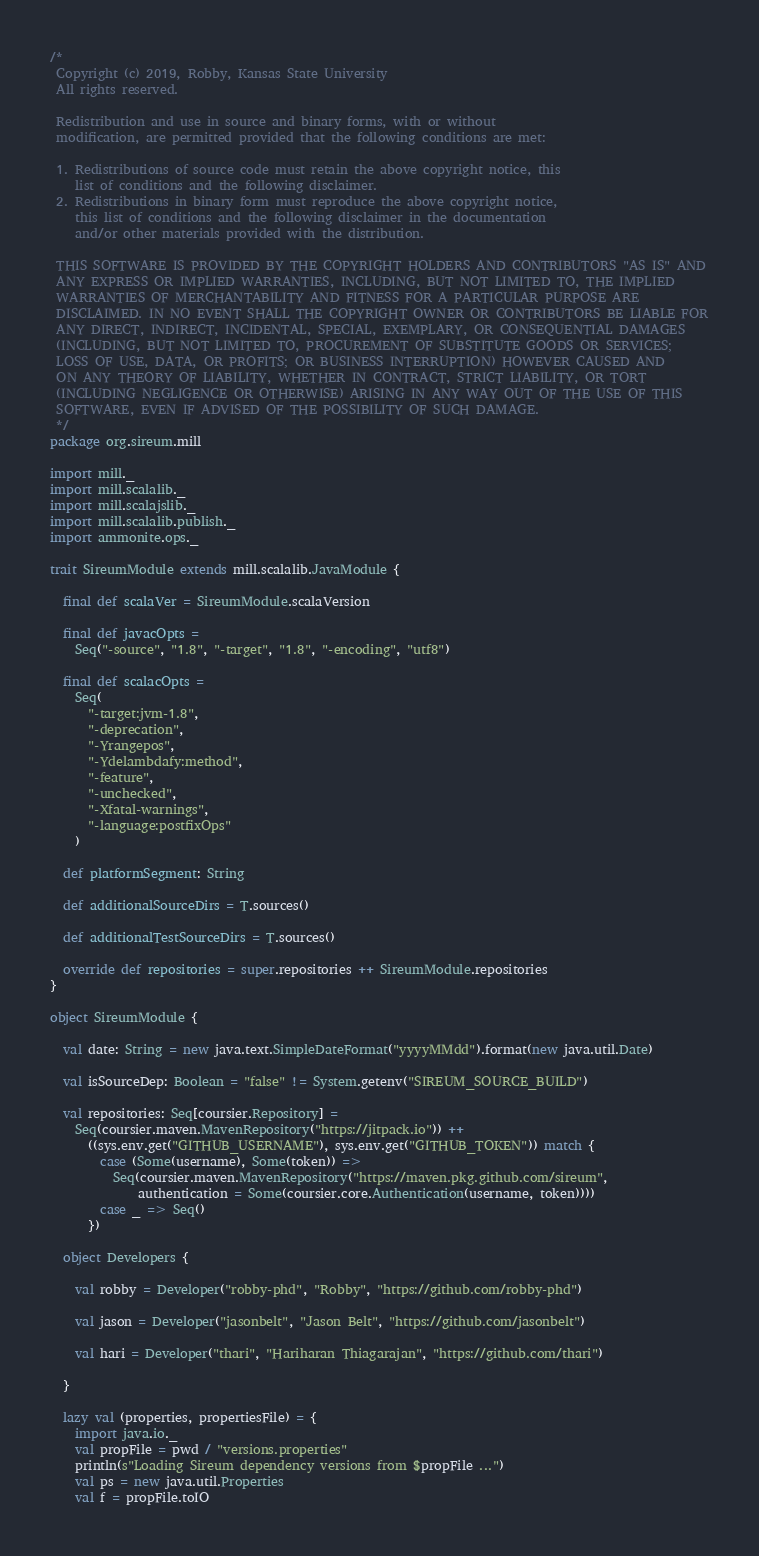<code> <loc_0><loc_0><loc_500><loc_500><_Scala_>/*
 Copyright (c) 2019, Robby, Kansas State University
 All rights reserved.

 Redistribution and use in source and binary forms, with or without
 modification, are permitted provided that the following conditions are met:

 1. Redistributions of source code must retain the above copyright notice, this
    list of conditions and the following disclaimer.
 2. Redistributions in binary form must reproduce the above copyright notice,
    this list of conditions and the following disclaimer in the documentation
    and/or other materials provided with the distribution.

 THIS SOFTWARE IS PROVIDED BY THE COPYRIGHT HOLDERS AND CONTRIBUTORS "AS IS" AND
 ANY EXPRESS OR IMPLIED WARRANTIES, INCLUDING, BUT NOT LIMITED TO, THE IMPLIED
 WARRANTIES OF MERCHANTABILITY AND FITNESS FOR A PARTICULAR PURPOSE ARE
 DISCLAIMED. IN NO EVENT SHALL THE COPYRIGHT OWNER OR CONTRIBUTORS BE LIABLE FOR
 ANY DIRECT, INDIRECT, INCIDENTAL, SPECIAL, EXEMPLARY, OR CONSEQUENTIAL DAMAGES
 (INCLUDING, BUT NOT LIMITED TO, PROCUREMENT OF SUBSTITUTE GOODS OR SERVICES;
 LOSS OF USE, DATA, OR PROFITS; OR BUSINESS INTERRUPTION) HOWEVER CAUSED AND
 ON ANY THEORY OF LIABILITY, WHETHER IN CONTRACT, STRICT LIABILITY, OR TORT
 (INCLUDING NEGLIGENCE OR OTHERWISE) ARISING IN ANY WAY OUT OF THE USE OF THIS
 SOFTWARE, EVEN IF ADVISED OF THE POSSIBILITY OF SUCH DAMAGE.
 */
package org.sireum.mill

import mill._
import mill.scalalib._
import mill.scalajslib._
import mill.scalalib.publish._
import ammonite.ops._

trait SireumModule extends mill.scalalib.JavaModule {

  final def scalaVer = SireumModule.scalaVersion

  final def javacOpts =
    Seq("-source", "1.8", "-target", "1.8", "-encoding", "utf8")

  final def scalacOpts =
    Seq(
      "-target:jvm-1.8",
      "-deprecation",
      "-Yrangepos",
      "-Ydelambdafy:method",
      "-feature",
      "-unchecked",
      "-Xfatal-warnings",
      "-language:postfixOps"
    )

  def platformSegment: String

  def additionalSourceDirs = T.sources()

  def additionalTestSourceDirs = T.sources()

  override def repositories = super.repositories ++ SireumModule.repositories
}

object SireumModule {

  val date: String = new java.text.SimpleDateFormat("yyyyMMdd").format(new java.util.Date)

  val isSourceDep: Boolean = "false" != System.getenv("SIREUM_SOURCE_BUILD")

  val repositories: Seq[coursier.Repository] =
    Seq(coursier.maven.MavenRepository("https://jitpack.io")) ++
      ((sys.env.get("GITHUB_USERNAME"), sys.env.get("GITHUB_TOKEN")) match {
        case (Some(username), Some(token)) =>
          Seq(coursier.maven.MavenRepository("https://maven.pkg.github.com/sireum",
              authentication = Some(coursier.core.Authentication(username, token))))
        case _ => Seq()
      })

  object Developers {

    val robby = Developer("robby-phd", "Robby", "https://github.com/robby-phd")

    val jason = Developer("jasonbelt", "Jason Belt", "https://github.com/jasonbelt")

    val hari = Developer("thari", "Hariharan Thiagarajan", "https://github.com/thari")

  }

  lazy val (properties, propertiesFile) = {
    import java.io._
    val propFile = pwd / "versions.properties"
    println(s"Loading Sireum dependency versions from $propFile ...")
    val ps = new java.util.Properties
    val f = propFile.toIO</code> 